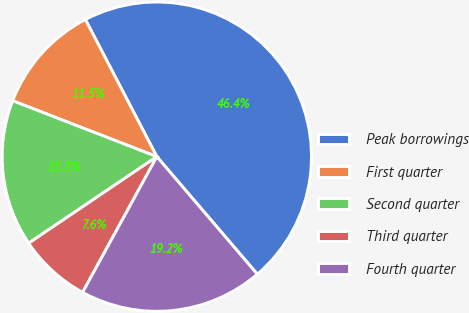Convert chart. <chart><loc_0><loc_0><loc_500><loc_500><pie_chart><fcel>Peak borrowings<fcel>First quarter<fcel>Second quarter<fcel>Third quarter<fcel>Fourth quarter<nl><fcel>46.38%<fcel>11.46%<fcel>15.34%<fcel>7.58%<fcel>19.22%<nl></chart> 